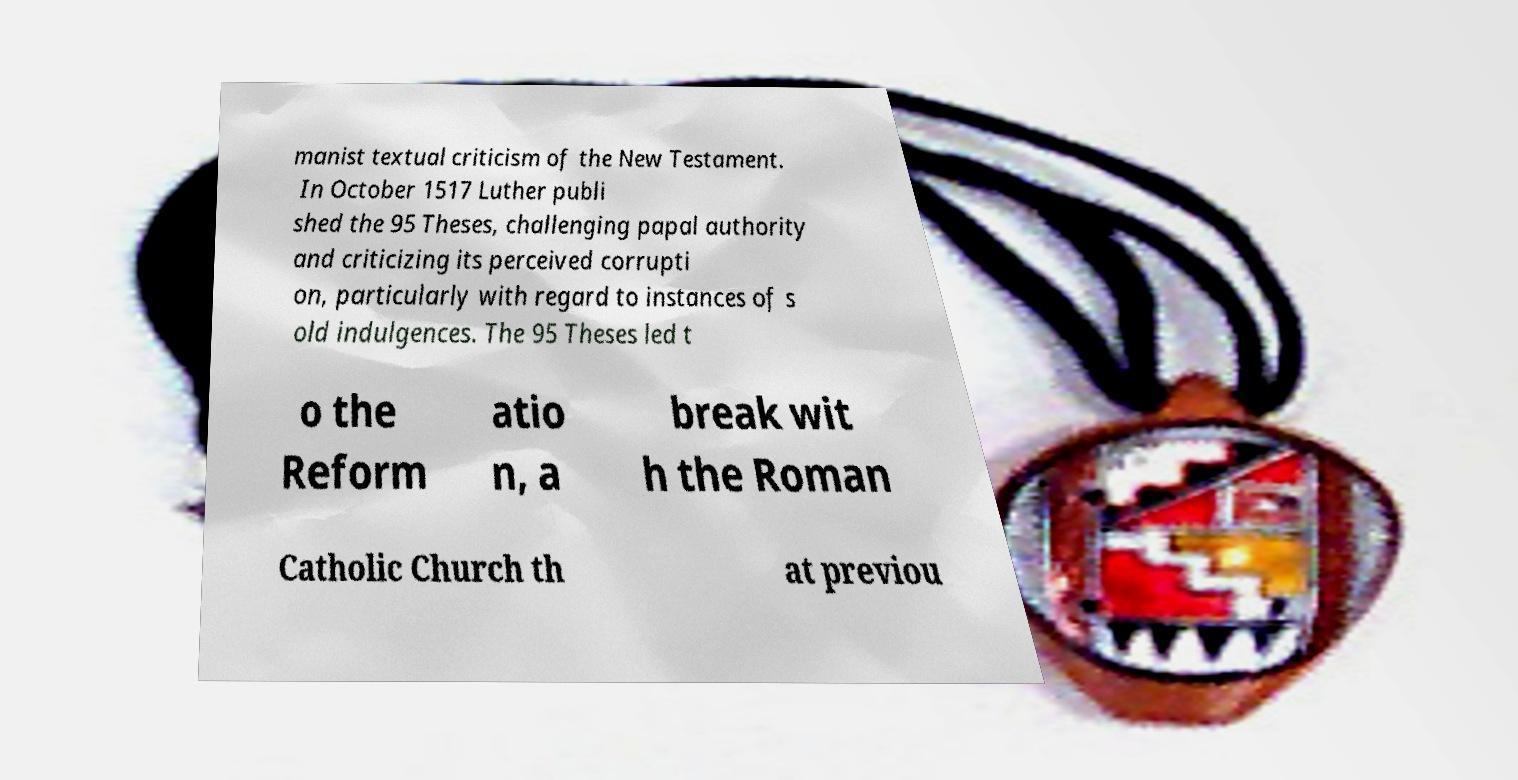For documentation purposes, I need the text within this image transcribed. Could you provide that? manist textual criticism of the New Testament. In October 1517 Luther publi shed the 95 Theses, challenging papal authority and criticizing its perceived corrupti on, particularly with regard to instances of s old indulgences. The 95 Theses led t o the Reform atio n, a break wit h the Roman Catholic Church th at previou 